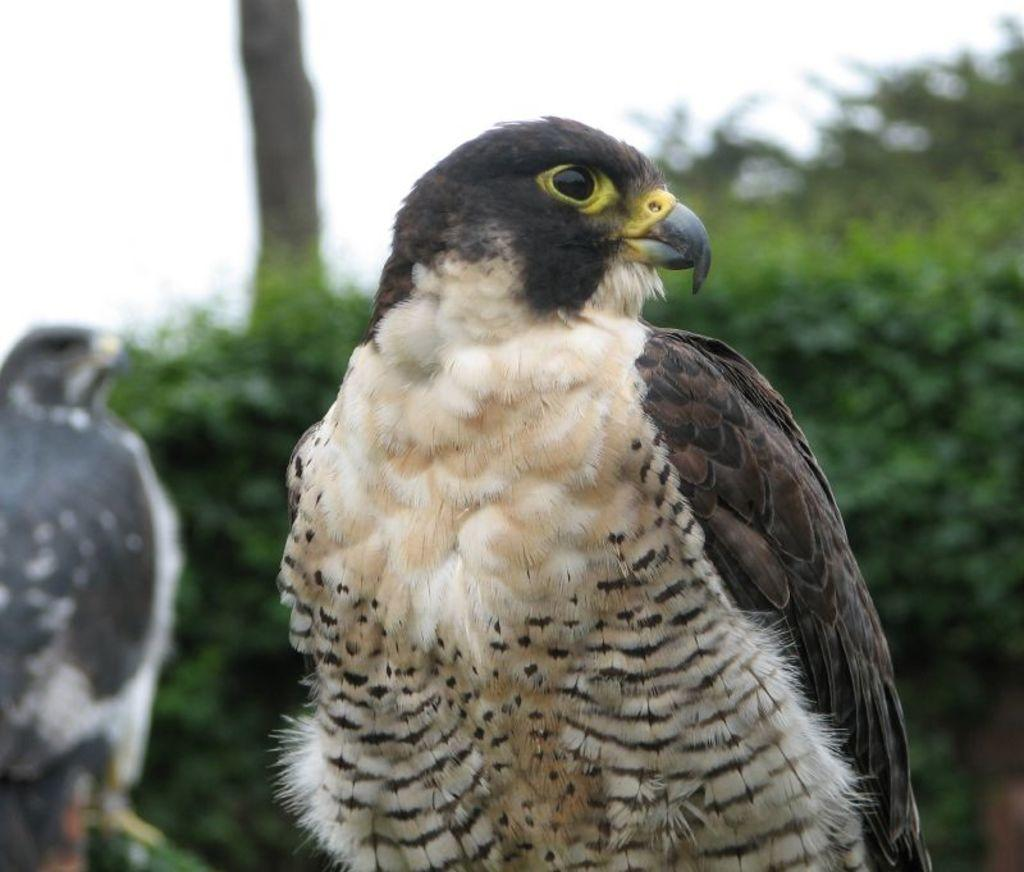What type of bird can be seen in the picture? There is an eagle in the picture. Can you describe the position of the second eagle in the picture? There is another eagle standing on bamboo in the picture. What can be seen in the background of the picture? There are plants visible in the background of the picture. What is visible at the top of the picture? The sky is visible at the top of the picture. What type of floor can be seen in the image? There is no floor visible in the image; it appears to be an outdoor scene with plants and the sky. 